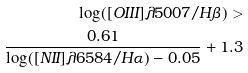Convert formula to latex. <formula><loc_0><loc_0><loc_500><loc_500>\log ( [ O I I I ] \lambda 5 0 0 7 / H \beta ) > \\ \frac { 0 . 6 1 } { \log ( [ N I I ] \lambda 6 5 8 4 / H \alpha ) - 0 . 0 5 } + 1 . 3</formula> 